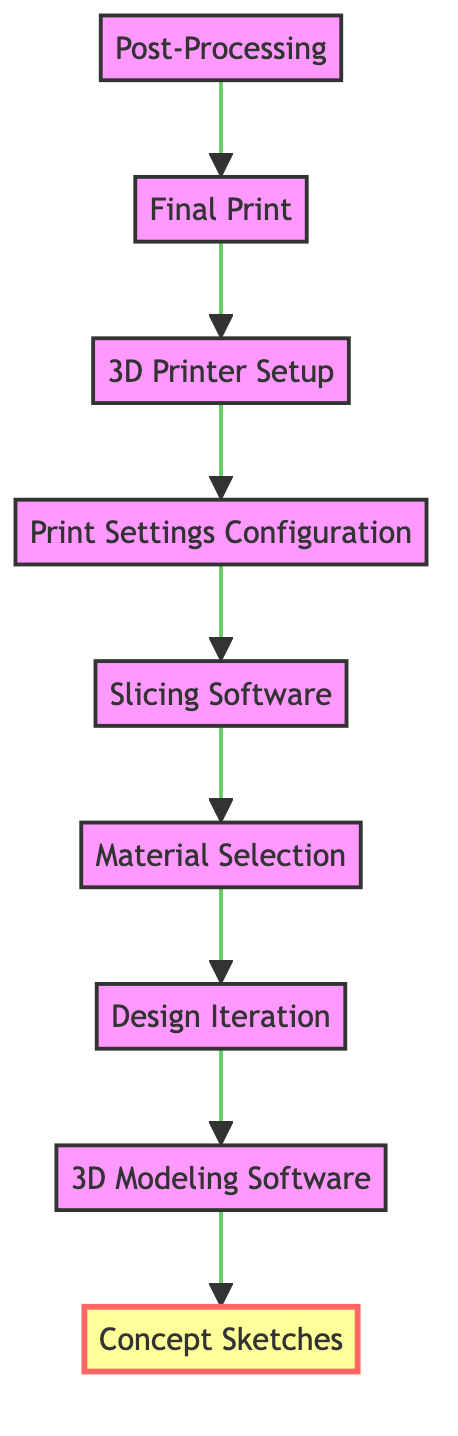What is the first step in the design process? The diagram indicates that the first step is "Concept Sketches." This can be identified as the top node in the flow chart, which represents the initial stage of the process.
Answer: Concept Sketches How many nodes are there in the diagram? By counting each unique step represented in the diagram, we find there are nine nodes: Concept Sketches, 3D Modeling Software, Design Iteration, Material Selection, Slicing Software, Print Settings Configuration, 3D Printer Setup, Final Print, and Post-Processing.
Answer: 9 What comes after "Slicing Software"? Traversing the flow bottom up, after "Slicing Software," the next node is "Print Settings Configuration." The arrows indicate the flow of the process, leading from one step to the next.
Answer: Print Settings Configuration Which step immediately follows "3D Printer Setup"? Based on the diagram, the step that immediately follows "3D Printer Setup" is "Final Print," as indicated by the direct connection between these two nodes.
Answer: Final Print What is the last step in this design process? The last step in the design process is "Post-Processing," which is the final node at the bottom of the flow chart, indicating the conclusion of the workflow.
Answer: Post-Processing What step is directly connected to "Design Iteration"? Directly connected to "Design Iteration" is "Material Selection." This shows the flow from refining the design to choosing appropriate materials based on the revised model.
Answer: Material Selection In what order do you go from "Concept Sketches" to "Post-Processing"? The order is: Concept Sketches → 3D Modeling Software → Design Iteration → Material Selection → Slicing Software → Print Settings Configuration → 3D Printer Setup → Final Print → Post-Processing. This sequence illustrates the entire flow from the initial idea to the finished product as per the diagram.
Answer: Concept Sketches, 3D Modeling Software, Design Iteration, Material Selection, Slicing Software, Print Settings Configuration, 3D Printer Setup, Final Print, Post-Processing What type of diagram is represented in this chart? The type of diagram represented is a Bottom Up Flow Chart, indicated by the structure that starts from a concept and flows downward through a process until the final output. This type highlights how one step builds on the previous ones to reach a conclusion.
Answer: Bottom Up Flow Chart 